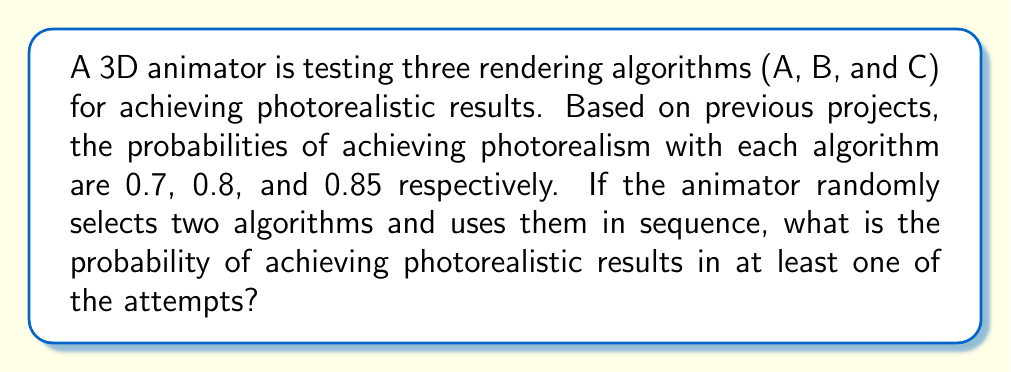Solve this math problem. Let's approach this step-by-step:

1) First, we need to calculate the probability of not achieving photorealism with each algorithm:
   A: $1 - 0.7 = 0.3$
   B: $1 - 0.8 = 0.2$
   C: $1 - 0.85 = 0.15$

2) There are three possible combinations of two algorithms:
   (A,B), (A,C), (B,C)

3) For each combination, we need to calculate the probability of not achieving photorealism in both attempts:
   
   (A,B): $0.3 \times 0.2 = 0.06$
   (A,C): $0.3 \times 0.15 = 0.045$
   (B,C): $0.2 \times 0.15 = 0.03$

4) The probability of selecting each combination is $\frac{1}{3}$, so we calculate the weighted average:

   $$P(\text{not photorealistic}) = \frac{1}{3}(0.06 + 0.045 + 0.03) = 0.045$$

5) Therefore, the probability of achieving photorealism in at least one attempt is:

   $$P(\text{photorealistic}) = 1 - P(\text{not photorealistic}) = 1 - 0.045 = 0.955$$

6) Converting to a percentage:

   $$0.955 \times 100\% = 95.5\%$$
Answer: 95.5% 